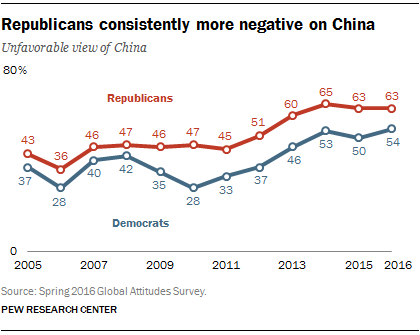Highlight a few significant elements in this photo. The color that represents Republicans with unfavorable views of China is red. In 2015, the total number of Republican and Democrats combined was 113. 